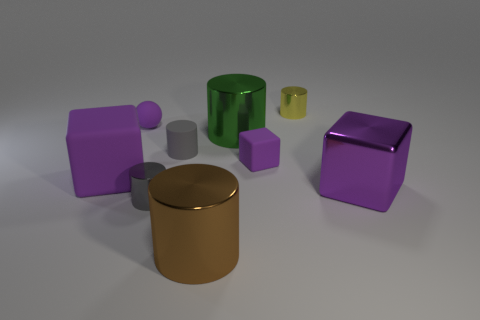Subtract all purple cubes. How many were subtracted if there are1purple cubes left? 2 Subtract all small yellow cylinders. How many cylinders are left? 4 Subtract all yellow cylinders. How many cylinders are left? 4 Subtract all yellow cylinders. Subtract all red cubes. How many cylinders are left? 4 Add 1 big brown cylinders. How many objects exist? 10 Subtract all blocks. How many objects are left? 6 Add 8 tiny gray matte objects. How many tiny gray matte objects exist? 9 Subtract 0 blue cylinders. How many objects are left? 9 Subtract all large brown rubber blocks. Subtract all metal cylinders. How many objects are left? 5 Add 7 large purple things. How many large purple things are left? 9 